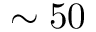<formula> <loc_0><loc_0><loc_500><loc_500>\sim 5 0</formula> 